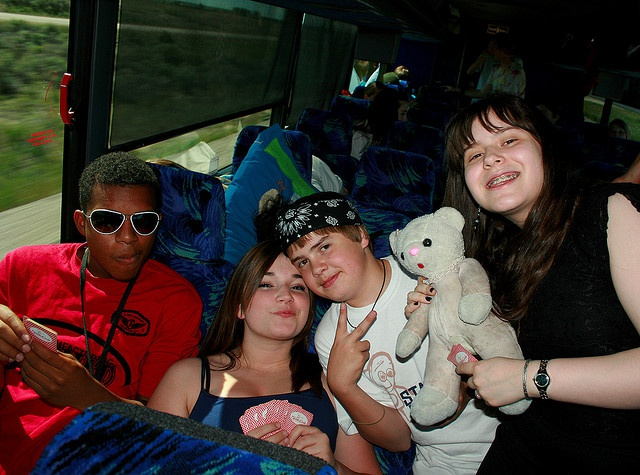Describe the objects in this image and their specific colors. I can see people in darkgreen, black, tan, and gray tones, people in darkgreen, maroon, black, and brown tones, people in darkgreen, darkgray, brown, black, and lightgray tones, people in darkgreen, black, brown, maroon, and salmon tones, and teddy bear in darkgreen, darkgray, lightgray, gray, and tan tones in this image. 